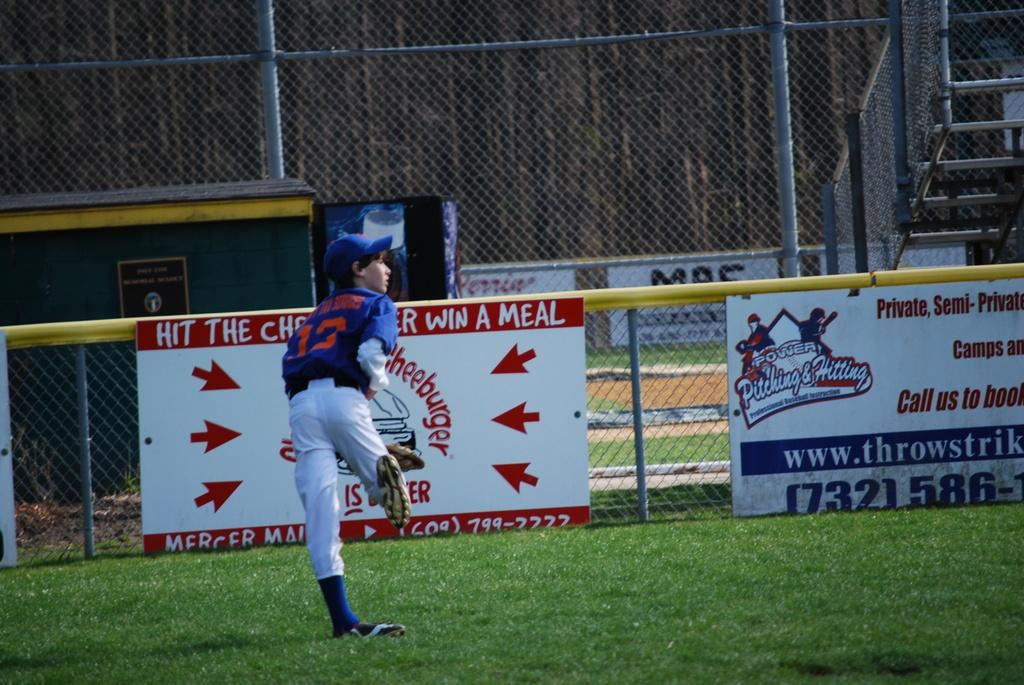Provide a one-sentence caption for the provided image. A baseball player stand on a field in front of a fence with an advertisement for Power Pitching & Hitting. 